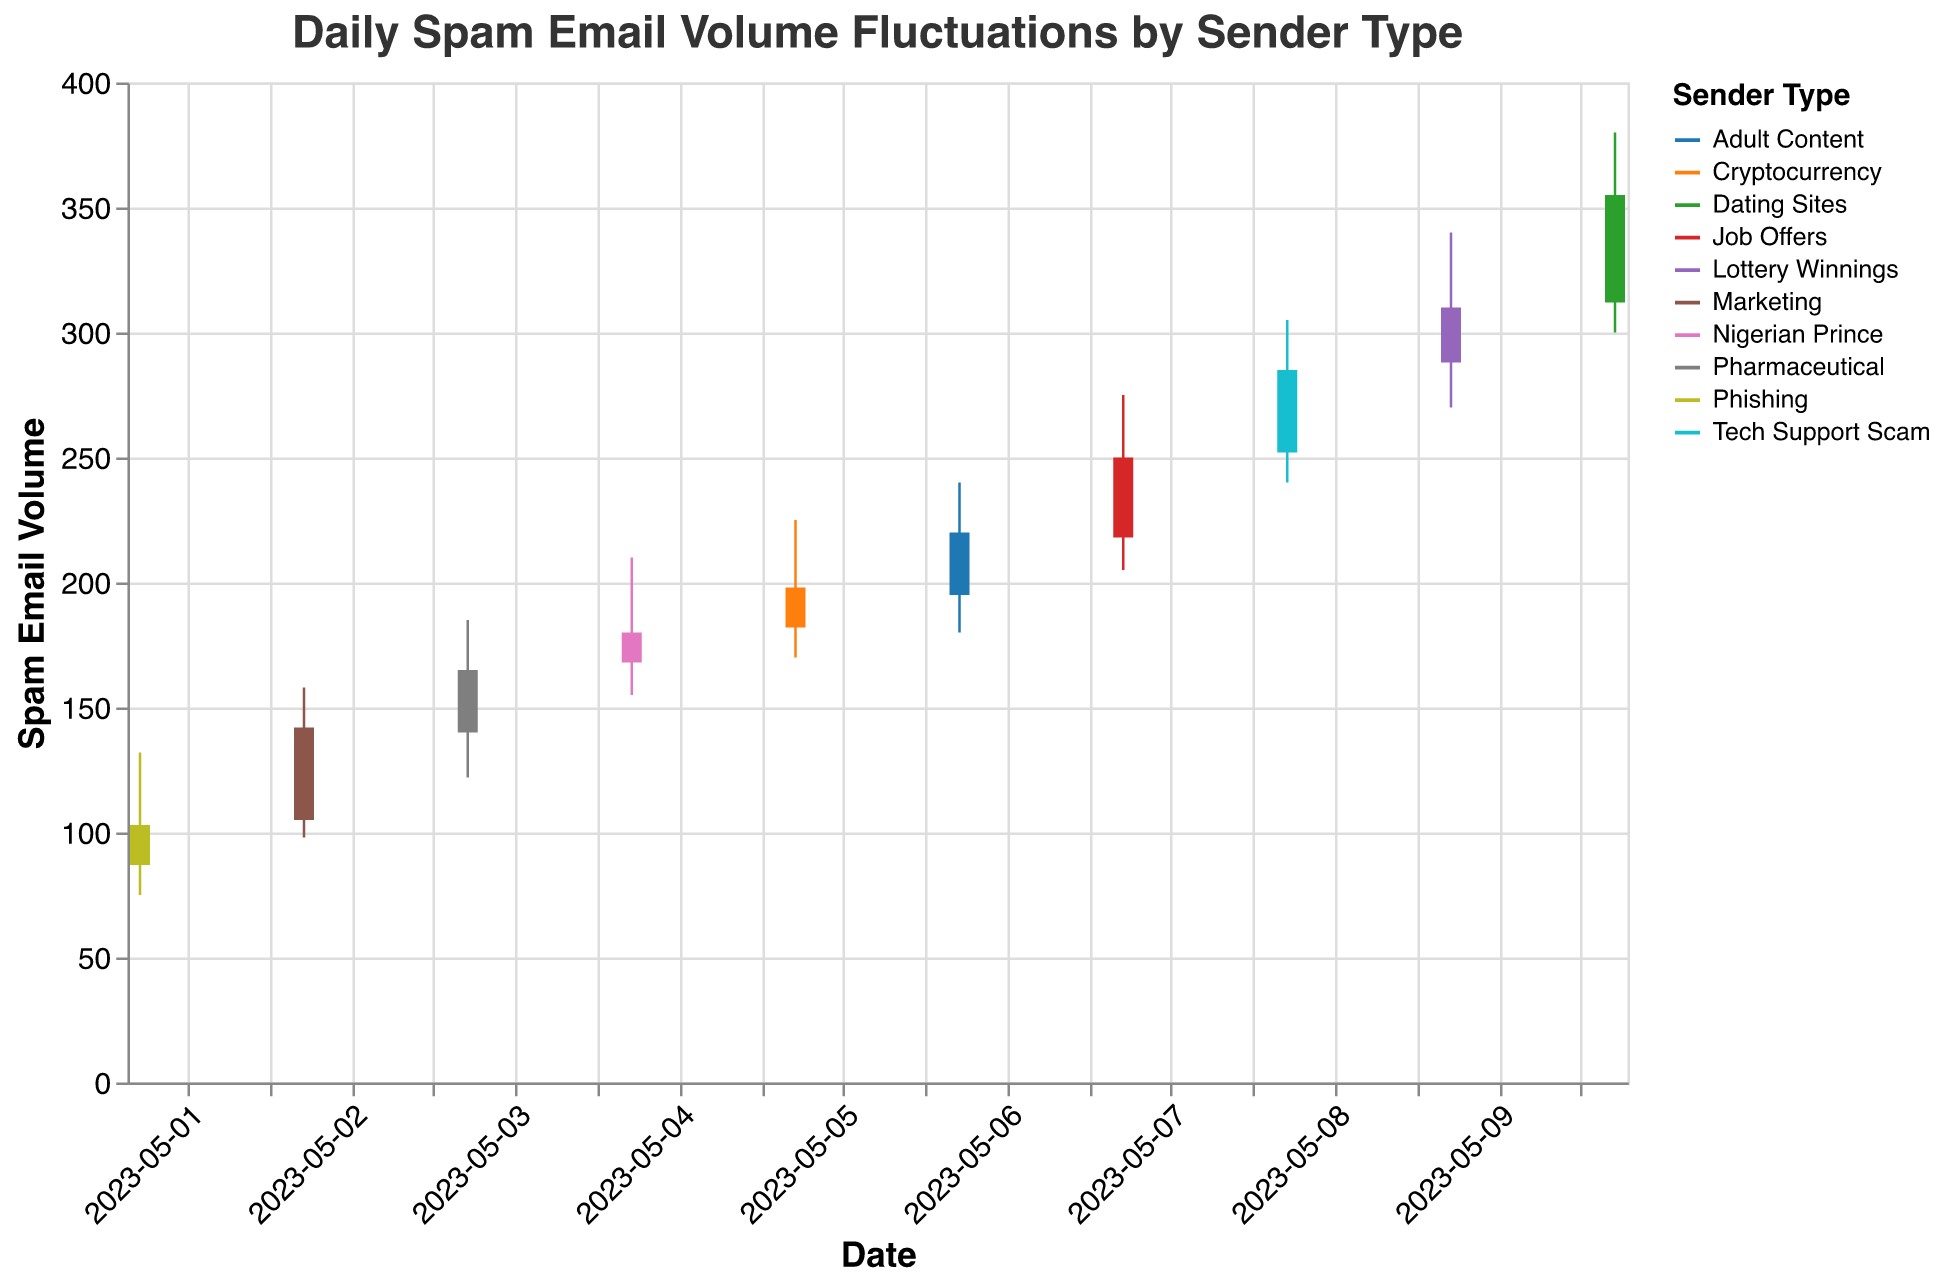What's the title of the chart? The title is typically displayed at the top of the chart. In this case, it is written as "Daily Spam Email Volume Fluctuations by Sender Type".
Answer: Daily Spam Email Volume Fluctuations by Sender Type How many different sender types are there? The legend shows all the distinct categories of sender types. By counting them, we find there are ten different types.
Answer: Ten What was the highest spam email volume from the "Lottery Winnings" sender type? Look for the high value associated with the "Lottery Winnings" sender type on May 9th, which is indicated by the highest point of the vertical line. The volume is 340.
Answer: 340 Which date had the lowest open volume, and what was that volume? The open volume can be found at the base of the vertical lines or the top of the bars. By examining the lowest numbers, May 1st has the lowest open volume at 87.
Answer: May 1st, 87 What was the spam volume range (difference between high and low) on May 10th? The high value is 380, and the low value is 300. The range is calculated by subtraction: 380 - 300 = 80.
Answer: 80 Which sender type had the highest close volume, and what was it? The close volume for each date is represented at the top of the bars. The highest close volume is on May 10th for the "Dating Sites" sender type, which is 355.
Answer: Dating Sites, 355 Did the spam volume generally increase or decrease over the 10-day period? By observing the overall trend of the close values from May 1st to May 10th, it starts at 103 and ends at 355, showing an increasing trend.
Answer: Increase Which day had the closest open and close volumes, and what were those volumes? We need to find the day where the difference between the open and close volumes is the smallest. May 1st has an open volume of 87 and a close volume of 103, making the difference 16.
Answer: May 1st, Open: 87, Close: 103 What was the average close volume for the entire period? To find the average, sum all close volumes from May 1st to May 10th: 103 + 142 + 165 + 180 + 198 + 220 + 250 + 285 + 310 + 355 = 2208. Then, divide by the number of days, which is 10. The average is 2208 / 10 = 220.8.
Answer: 220.8 Which day had the most significant increase in high spam volume compared to the previous day, and what was that increase? Calculate the difference in high values between consecutive days. The highest increase is from May 8th (305) to May 9th (340), an increase of 35.
Answer: May 9th, 35 